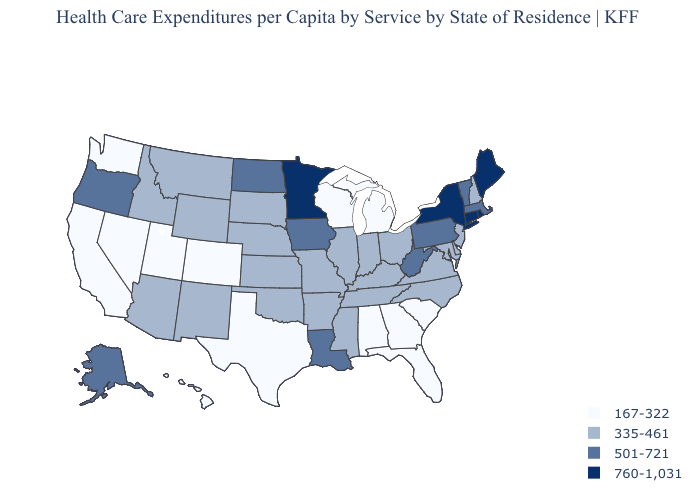What is the value of Iowa?
Be succinct. 501-721. Is the legend a continuous bar?
Give a very brief answer. No. Among the states that border New York , does Pennsylvania have the highest value?
Be succinct. No. What is the value of Arkansas?
Quick response, please. 335-461. Name the states that have a value in the range 335-461?
Keep it brief. Arizona, Arkansas, Delaware, Idaho, Illinois, Indiana, Kansas, Kentucky, Maryland, Mississippi, Missouri, Montana, Nebraska, New Hampshire, New Jersey, New Mexico, North Carolina, Ohio, Oklahoma, South Dakota, Tennessee, Virginia, Wyoming. What is the highest value in states that border Illinois?
Short answer required. 501-721. Name the states that have a value in the range 335-461?
Quick response, please. Arizona, Arkansas, Delaware, Idaho, Illinois, Indiana, Kansas, Kentucky, Maryland, Mississippi, Missouri, Montana, Nebraska, New Hampshire, New Jersey, New Mexico, North Carolina, Ohio, Oklahoma, South Dakota, Tennessee, Virginia, Wyoming. Does Iowa have the same value as North Dakota?
Answer briefly. Yes. Does Texas have the same value as North Dakota?
Quick response, please. No. Among the states that border Wisconsin , does Michigan have the lowest value?
Concise answer only. Yes. Does Delaware have the highest value in the USA?
Keep it brief. No. Name the states that have a value in the range 760-1,031?
Be succinct. Connecticut, Maine, Minnesota, New York, Rhode Island. Name the states that have a value in the range 335-461?
Concise answer only. Arizona, Arkansas, Delaware, Idaho, Illinois, Indiana, Kansas, Kentucky, Maryland, Mississippi, Missouri, Montana, Nebraska, New Hampshire, New Jersey, New Mexico, North Carolina, Ohio, Oklahoma, South Dakota, Tennessee, Virginia, Wyoming. What is the lowest value in the USA?
Keep it brief. 167-322. Name the states that have a value in the range 501-721?
Write a very short answer. Alaska, Iowa, Louisiana, Massachusetts, North Dakota, Oregon, Pennsylvania, Vermont, West Virginia. 